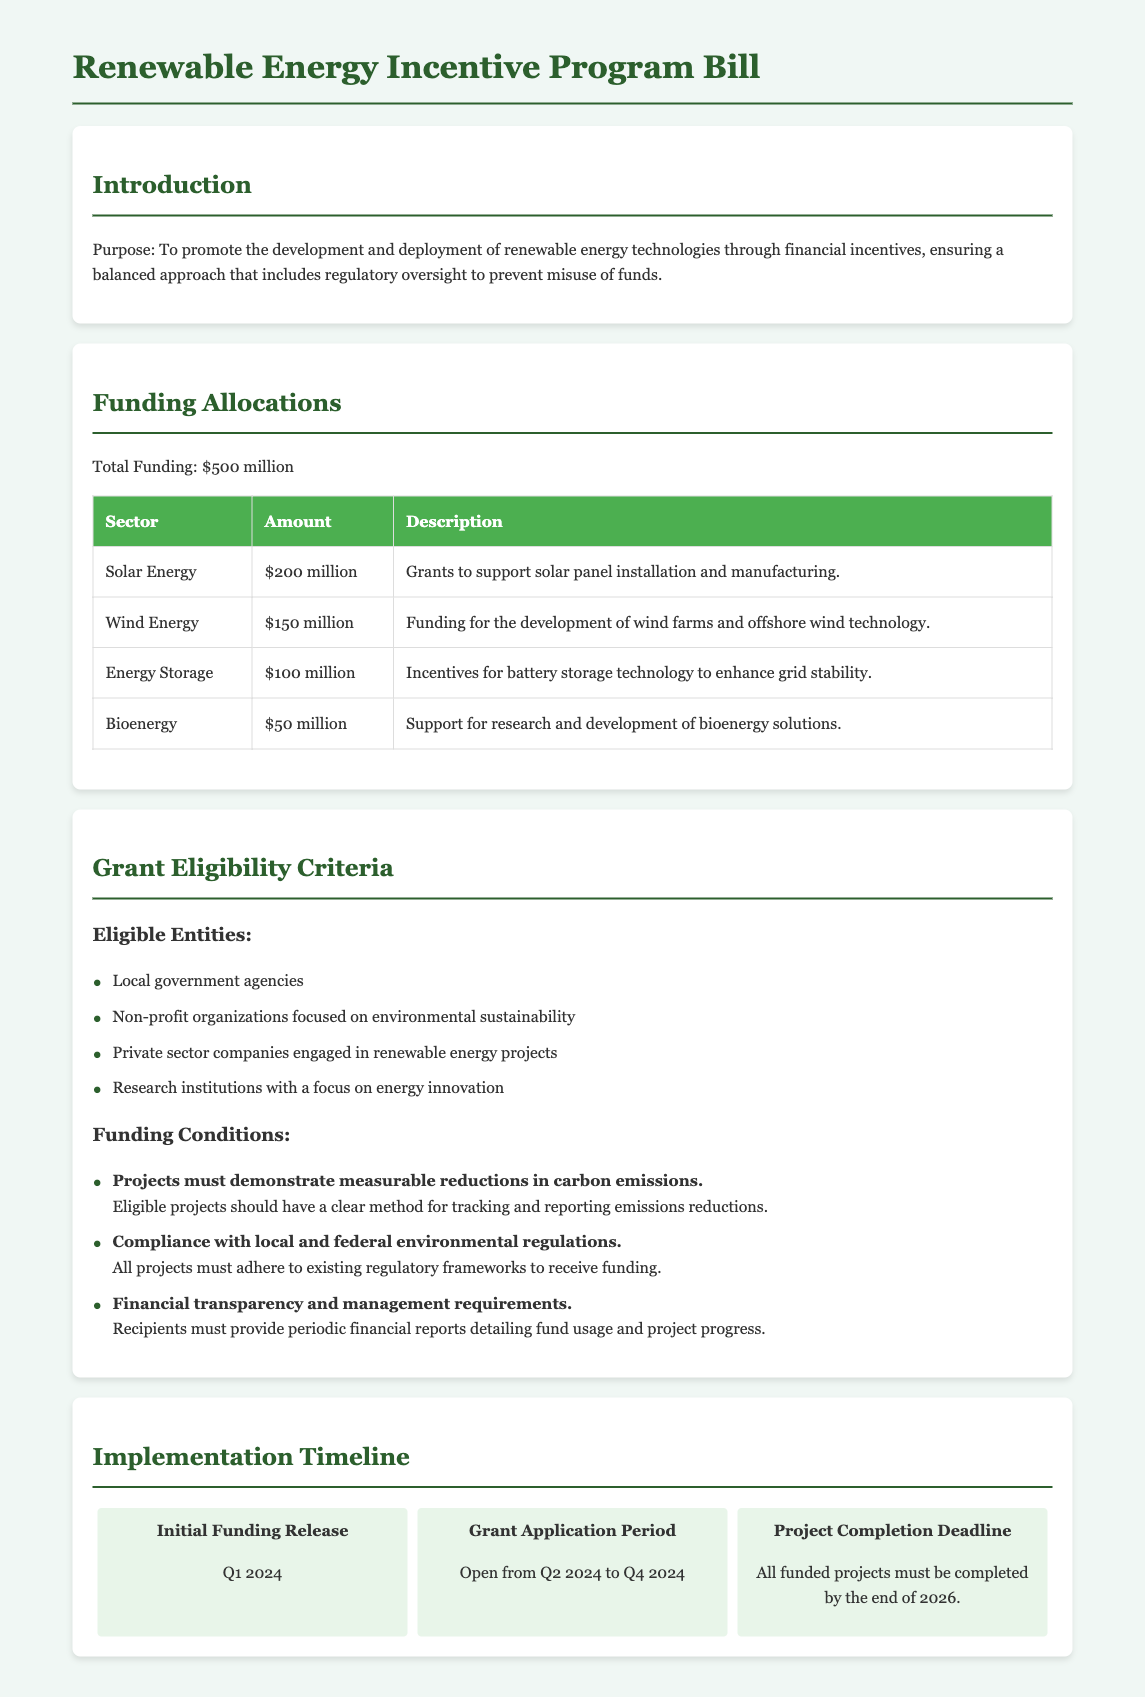What is the total funding allocated for the program? The total funding is clearly stated in the document as $500 million.
Answer: $500 million How much funding is allocated for solar energy? The document specifies that solar energy receives funding of $200 million.
Answer: $200 million Who can be an eligible entity for grants? The document lists eligible entities including local government agencies, non-profit organizations, private sector companies, and research institutions.
Answer: Local government agencies What is the project completion deadline? The document mentions that all funded projects must be completed by the end of 2026.
Answer: End of 2026 What percentage of the total funding is allocated to wind energy? To find this, we calculate the allocation: $150 million out of $500 million, which is 30%.
Answer: 30% What are recipients required to demonstrate to be eligible for funding? Recipients must demonstrate measurable reductions in carbon emissions as part of the funding conditions.
Answer: Measurable reductions in carbon emissions When does the grant application period open? The document specifies that the grant application period opens in Q2 2024.
Answer: Q2 2024 What is the funding allocation for bioenergy? The document states that bioenergy is allocated $50 million.
Answer: $50 million What must projects comply with to receive funding? The document states that all projects must comply with local and federal environmental regulations.
Answer: Local and federal environmental regulations 